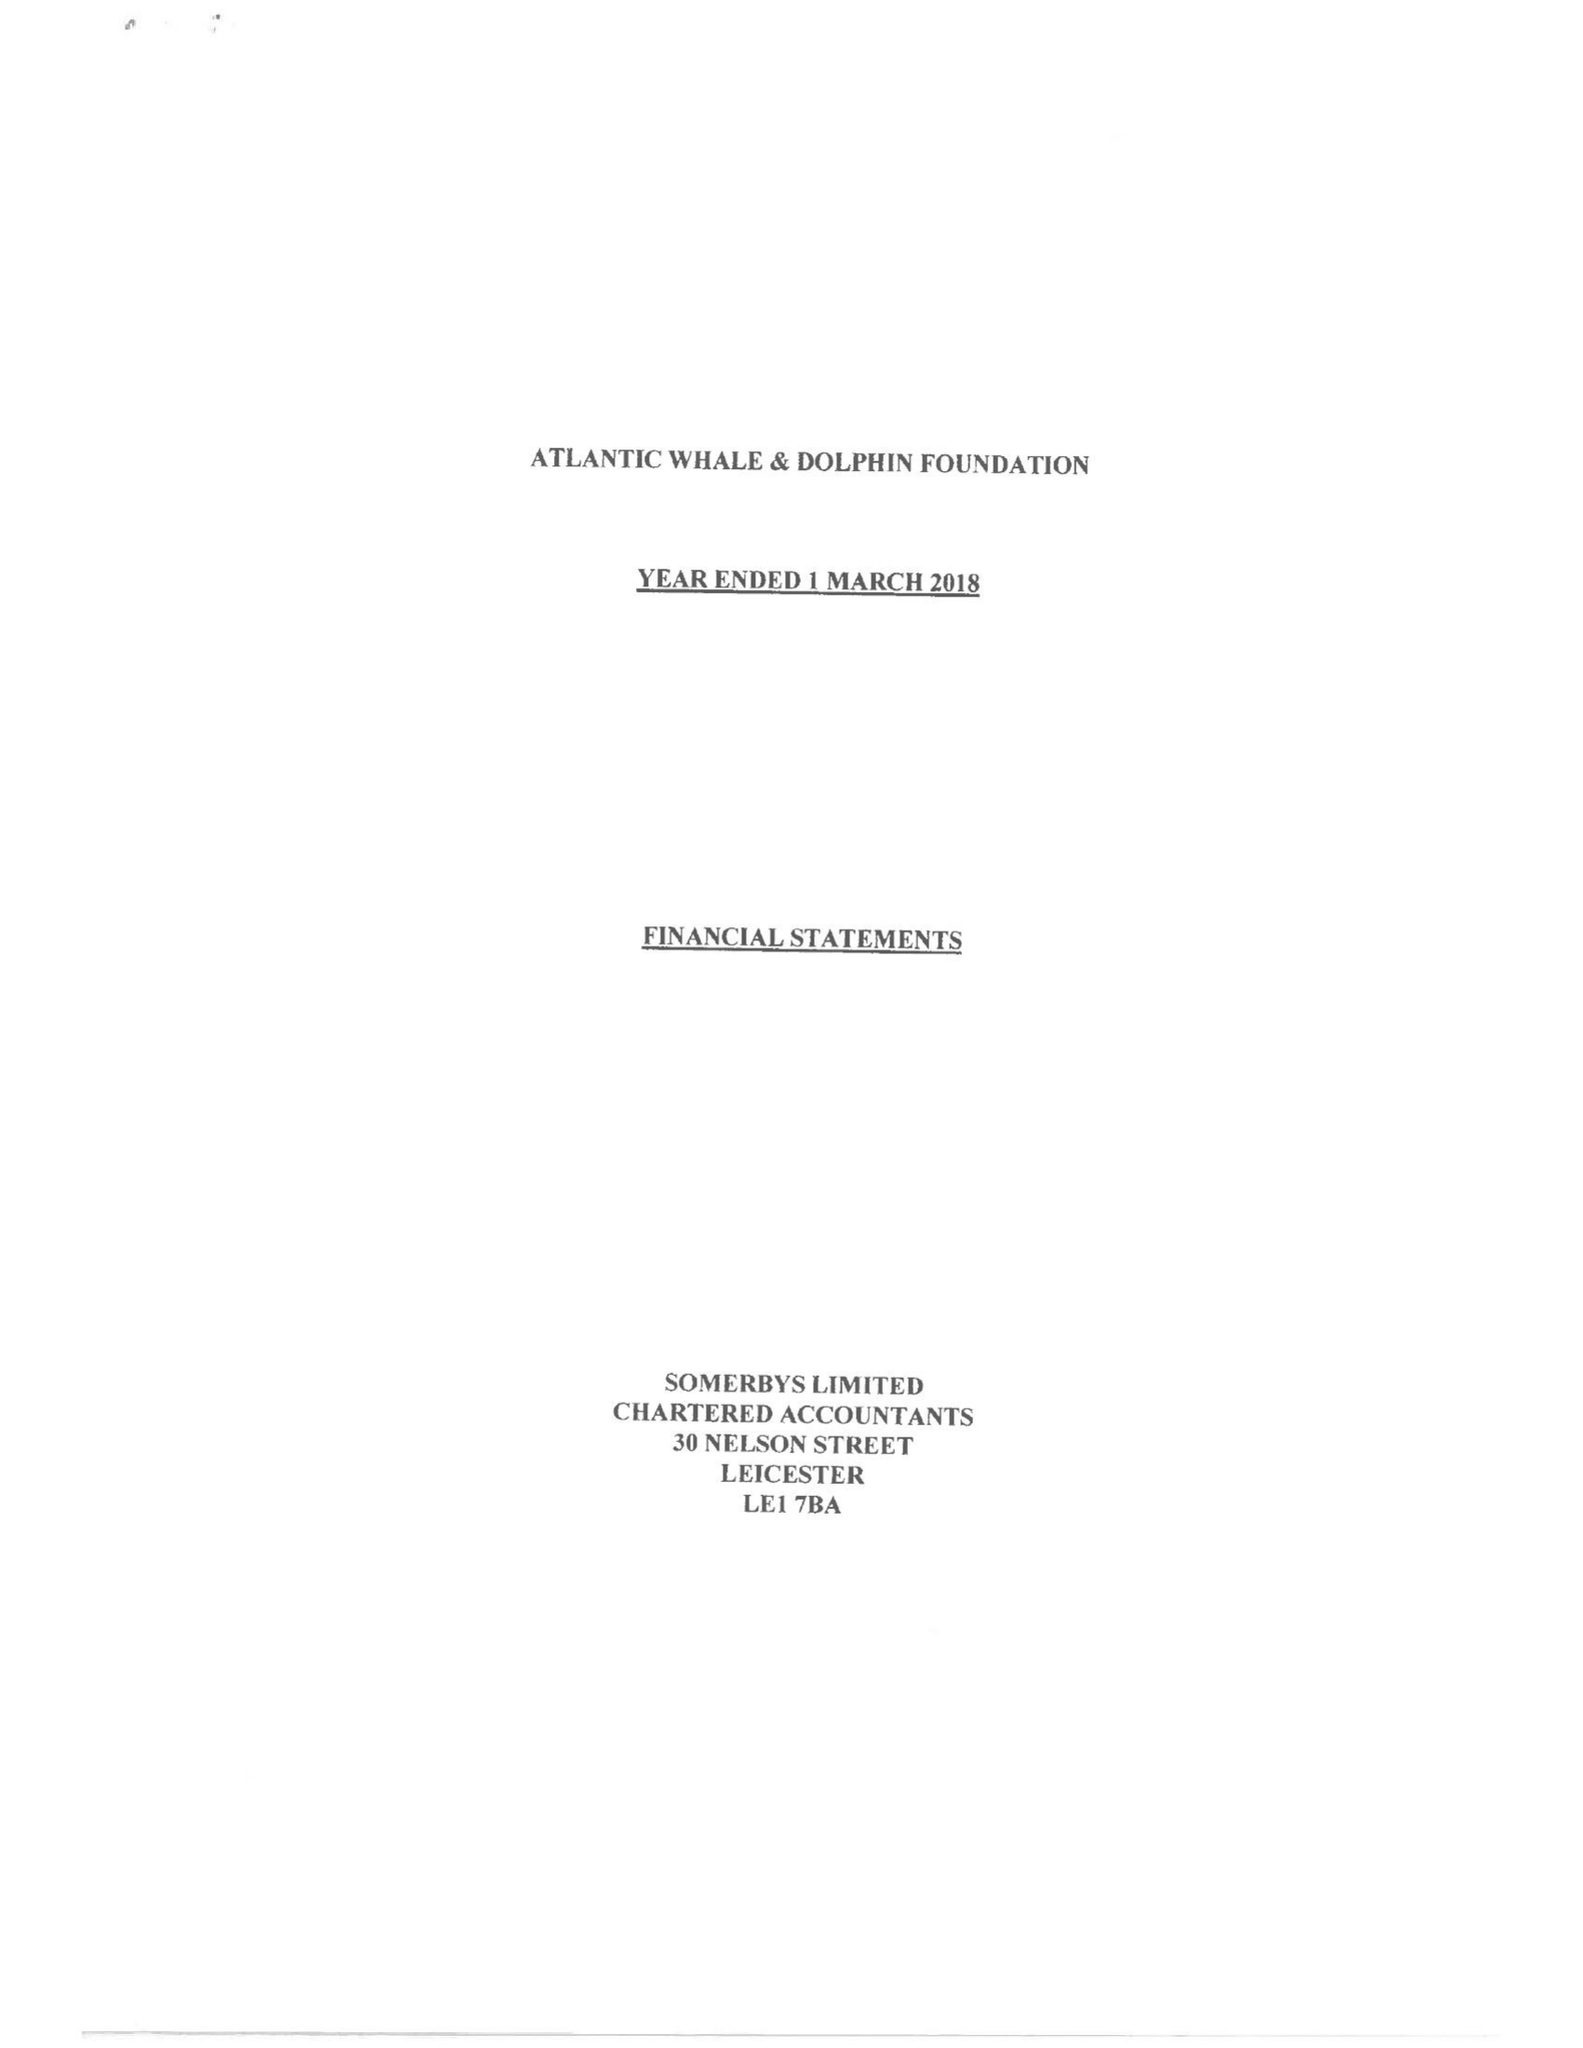What is the value for the charity_name?
Answer the question using a single word or phrase. Atlantic Whale and Dolphin Foundation 